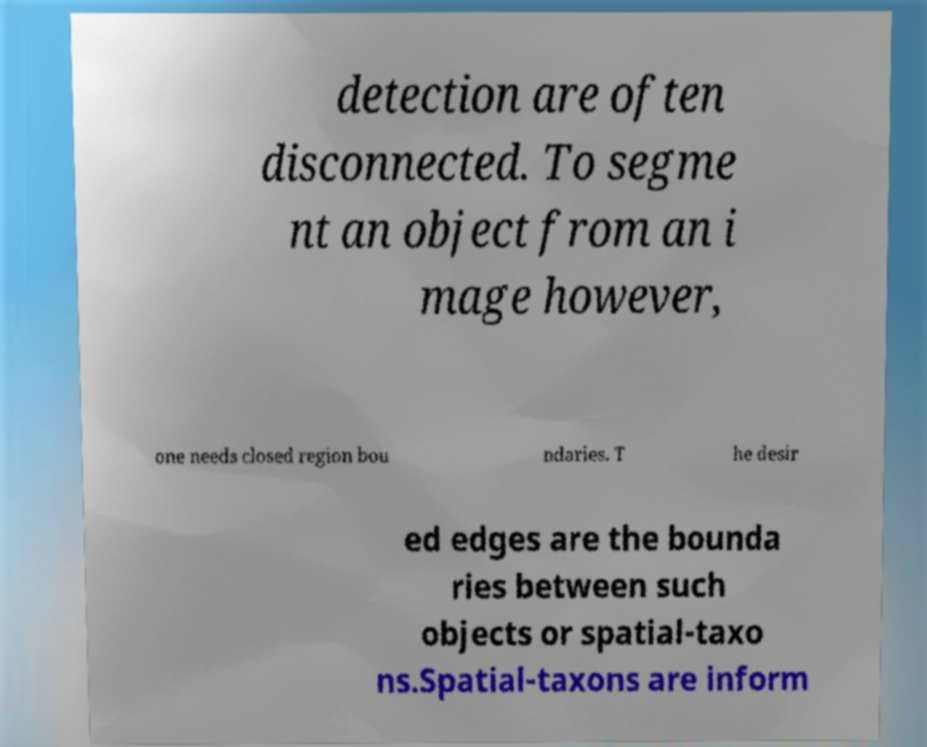For documentation purposes, I need the text within this image transcribed. Could you provide that? detection are often disconnected. To segme nt an object from an i mage however, one needs closed region bou ndaries. T he desir ed edges are the bounda ries between such objects or spatial-taxo ns.Spatial-taxons are inform 